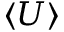Convert formula to latex. <formula><loc_0><loc_0><loc_500><loc_500>\langle U \rangle</formula> 